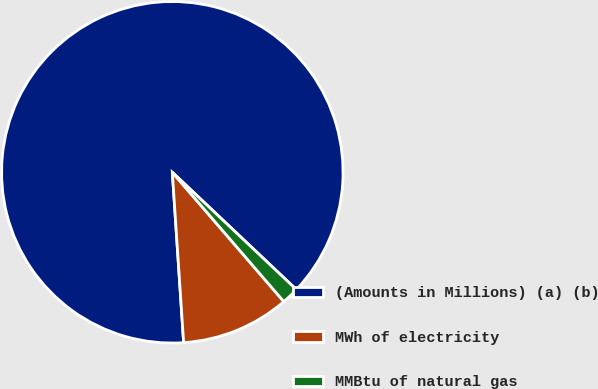<chart> <loc_0><loc_0><loc_500><loc_500><pie_chart><fcel>(Amounts in Millions) (a) (b)<fcel>MWh of electricity<fcel>MMBtu of natural gas<nl><fcel>88.12%<fcel>10.27%<fcel>1.62%<nl></chart> 